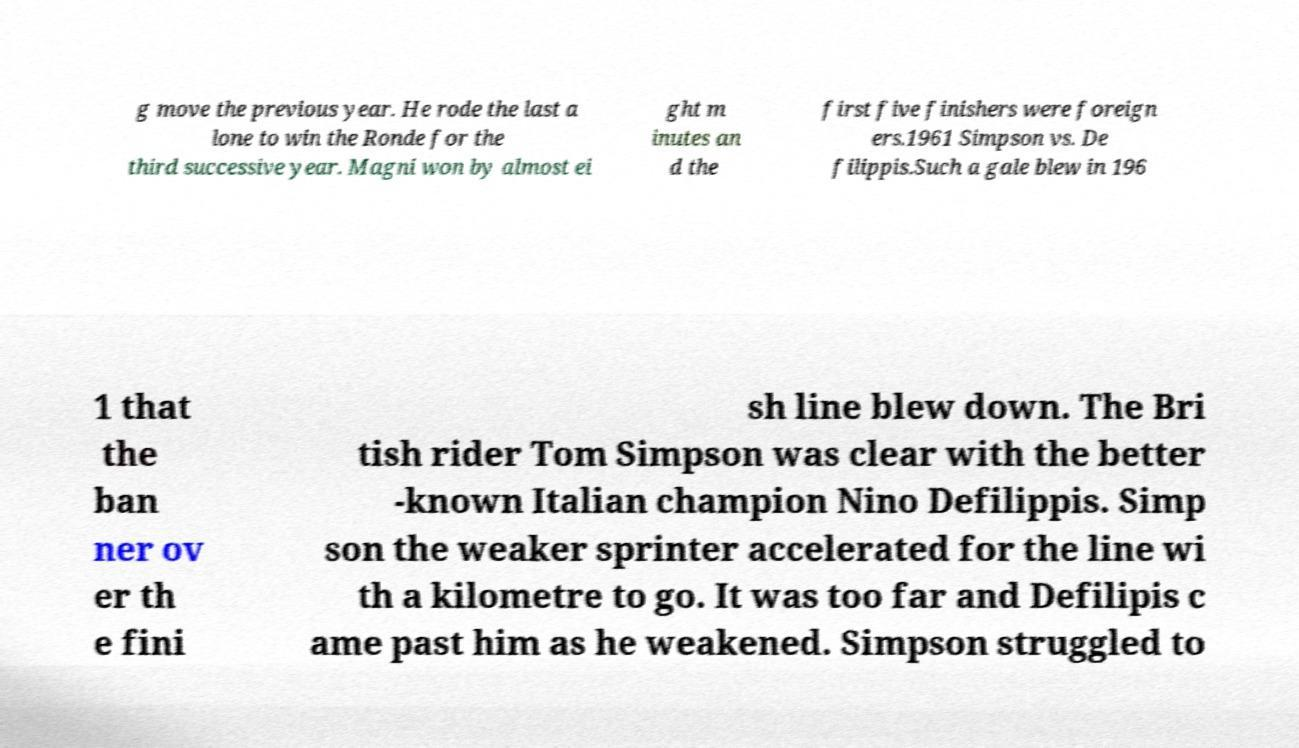There's text embedded in this image that I need extracted. Can you transcribe it verbatim? g move the previous year. He rode the last a lone to win the Ronde for the third successive year. Magni won by almost ei ght m inutes an d the first five finishers were foreign ers.1961 Simpson vs. De filippis.Such a gale blew in 196 1 that the ban ner ov er th e fini sh line blew down. The Bri tish rider Tom Simpson was clear with the better -known Italian champion Nino Defilippis. Simp son the weaker sprinter accelerated for the line wi th a kilometre to go. It was too far and Defilipis c ame past him as he weakened. Simpson struggled to 